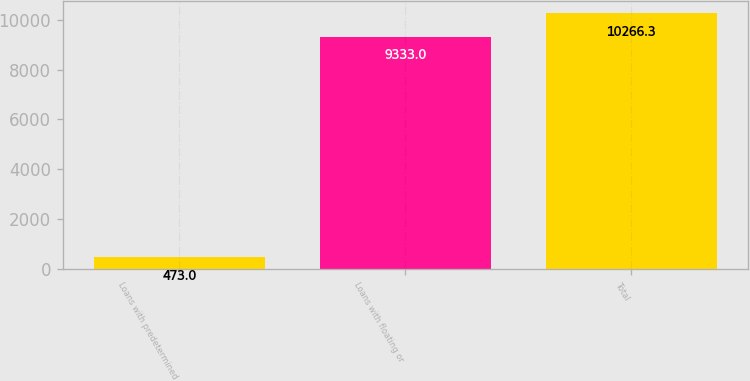Convert chart to OTSL. <chart><loc_0><loc_0><loc_500><loc_500><bar_chart><fcel>Loans with predetermined<fcel>Loans with floating or<fcel>Total<nl><fcel>473<fcel>9333<fcel>10266.3<nl></chart> 